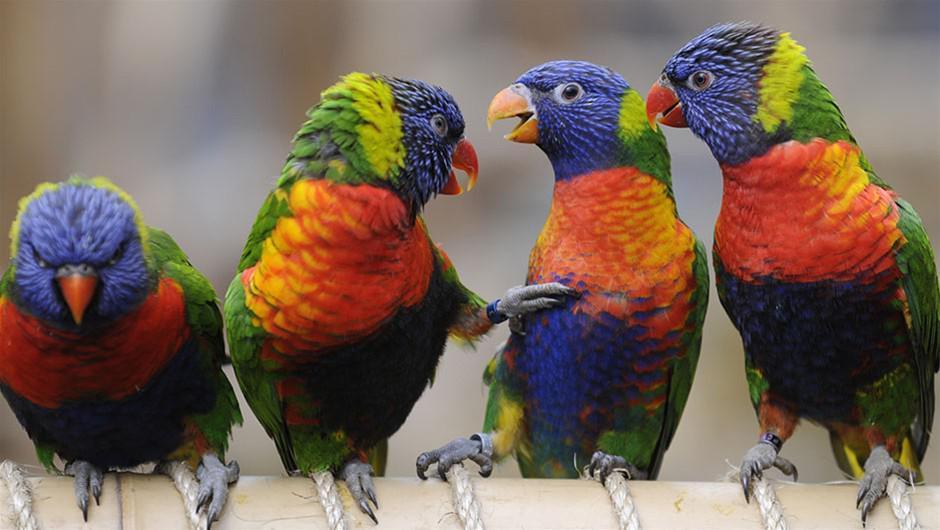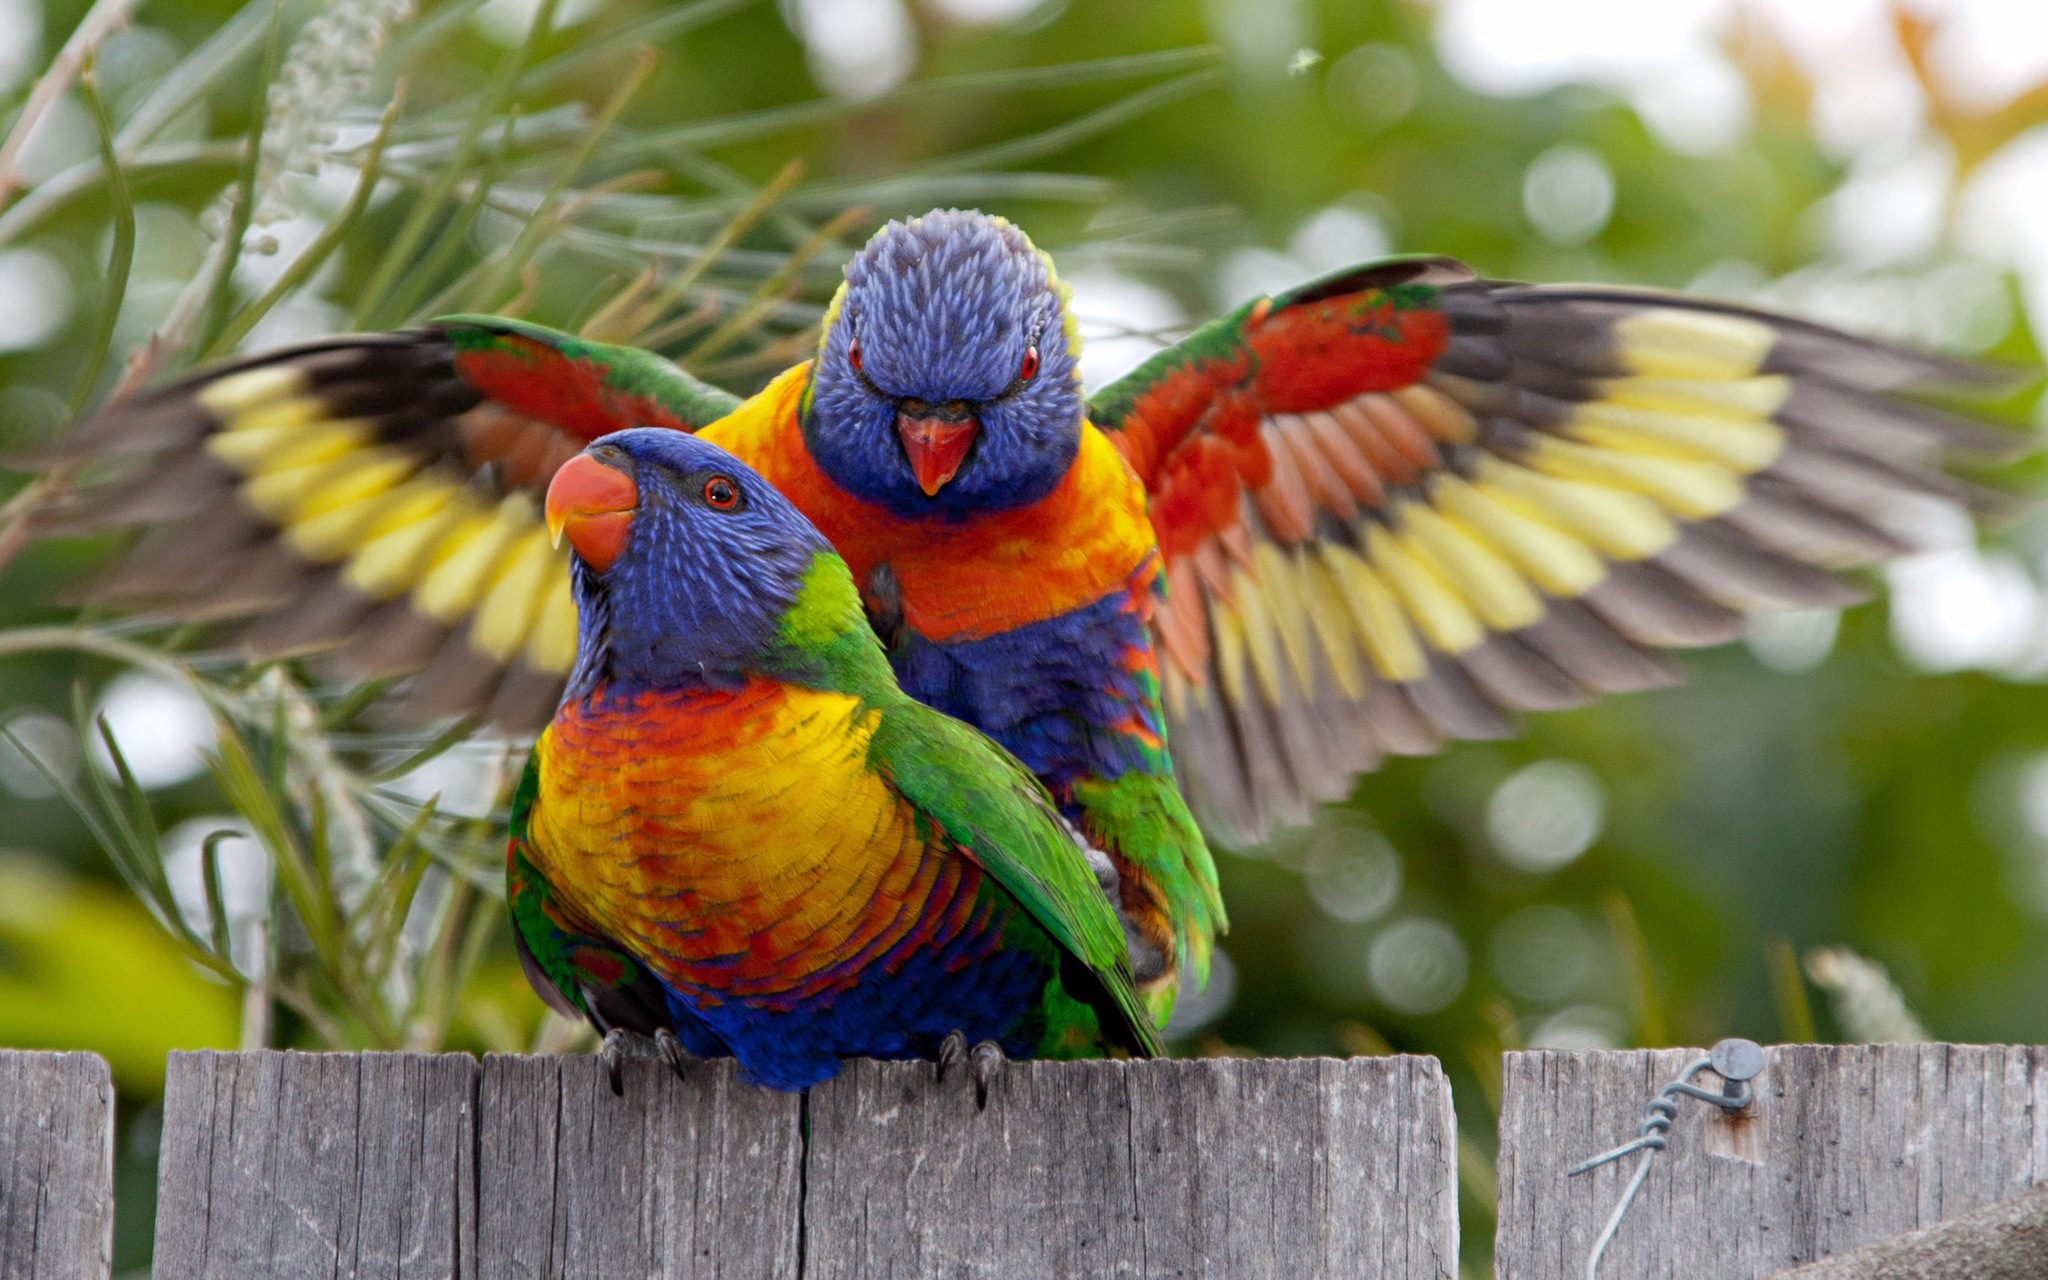The first image is the image on the left, the second image is the image on the right. Considering the images on both sides, is "There are three birds" valid? Answer yes or no. No. The first image is the image on the left, the second image is the image on the right. For the images shown, is this caption "There are three birds perched on something." true? Answer yes or no. No. 